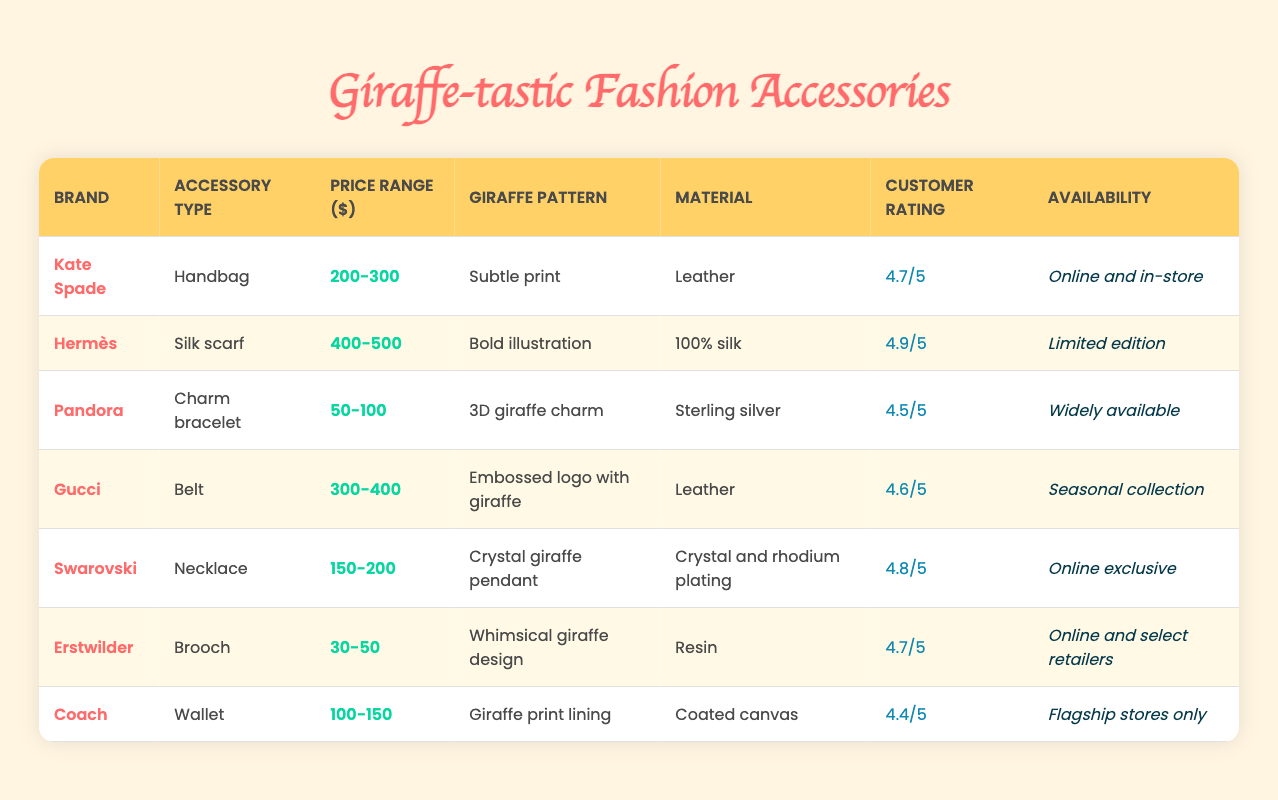What is the customer rating for the Gucci belt? The customer rating for Gucci is listed in the table as 4.6/5.
Answer: 4.6/5 Which accessory has the highest price range? The Hermès silk scarf has the highest price range listed at 400-500 dollars.
Answer: 400-500 How many accessories have a customer rating of 4.7 or higher? The accessories with ratings of 4.7 or higher are Kate Spade (4.7), Hermès (4.9), Swarovski (4.8), and Erstwilder (4.7), which totals four accessories.
Answer: 4 Does the Pandora charm bracelet have a giraffe pattern? Yes, the Pandora charm bracelet features a 3D giraffe charm as part of its design.
Answer: Yes What is the average price range of the accessories offered in this table? The price ranges are: 200-300 (Kate Spade), 400-500 (Hermès), 50-100 (Pandora), 300-400 (Gucci), 150-200 (Swarovski), 30-50 (Erstwilder), 100-150 (Coach). Converting these to midpoints gives us (250 + 450 + 75 + 350 + 175 + 40 + 125)/7 = 167.86.
Answer: 167.86 Which brand offers a giraffe-themed product that is widely available? The Pandora brand offers a charm bracelet with a 3D giraffe charm and it is widely available.
Answer: Pandora How does the material of the Hermès silk scarf compare with the others? The Hermès silk scarf is made of 100% silk, which is a more luxurious material compared to the leather used by Kate Spade and Gucci, the coated canvas of Coach, or the resin of Erstwilder.
Answer: 100% silk What accessory features a whimsical giraffe design? The Erstwilder brooch features a whimsical giraffe design as indicated in the table.
Answer: Erstwilder brooch 